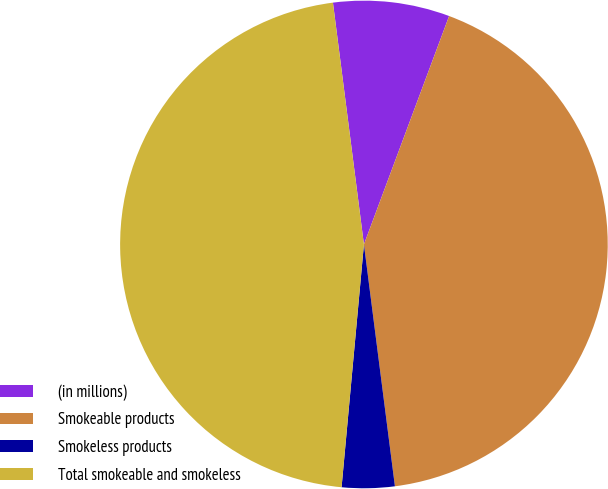Convert chart. <chart><loc_0><loc_0><loc_500><loc_500><pie_chart><fcel>(in millions)<fcel>Smokeable products<fcel>Smokeless products<fcel>Total smokeable and smokeless<nl><fcel>7.71%<fcel>42.29%<fcel>3.49%<fcel>46.51%<nl></chart> 